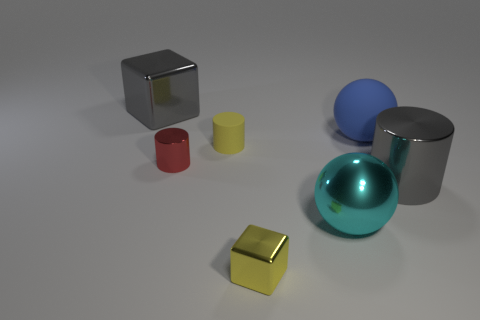Can you tell me the colors of the spherical objects? Certainly! There are two spherical objects: one is blue and the other is a shiny turquoise or teal color. 